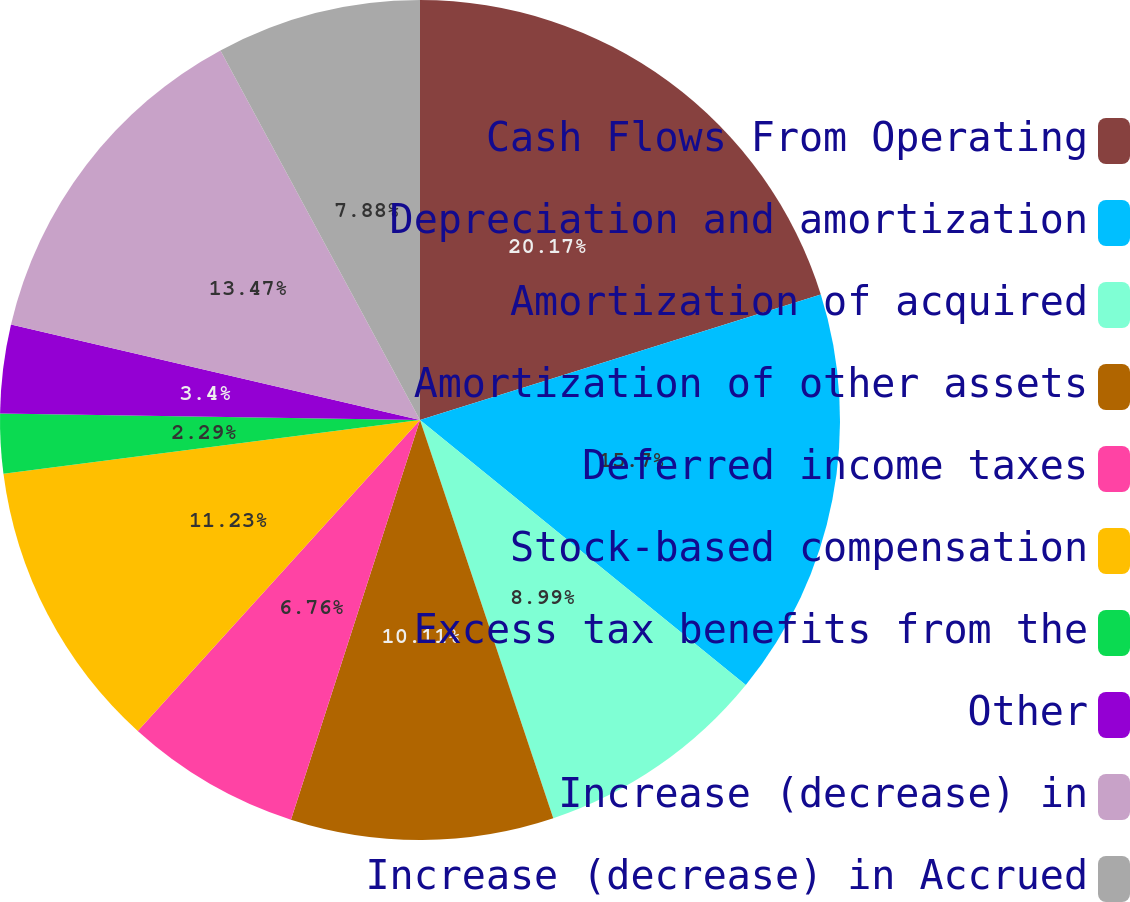Convert chart to OTSL. <chart><loc_0><loc_0><loc_500><loc_500><pie_chart><fcel>Cash Flows From Operating<fcel>Depreciation and amortization<fcel>Amortization of acquired<fcel>Amortization of other assets<fcel>Deferred income taxes<fcel>Stock-based compensation<fcel>Excess tax benefits from the<fcel>Other<fcel>Increase (decrease) in<fcel>Increase (decrease) in Accrued<nl><fcel>20.17%<fcel>15.7%<fcel>8.99%<fcel>10.11%<fcel>6.76%<fcel>11.23%<fcel>2.29%<fcel>3.4%<fcel>13.47%<fcel>7.88%<nl></chart> 